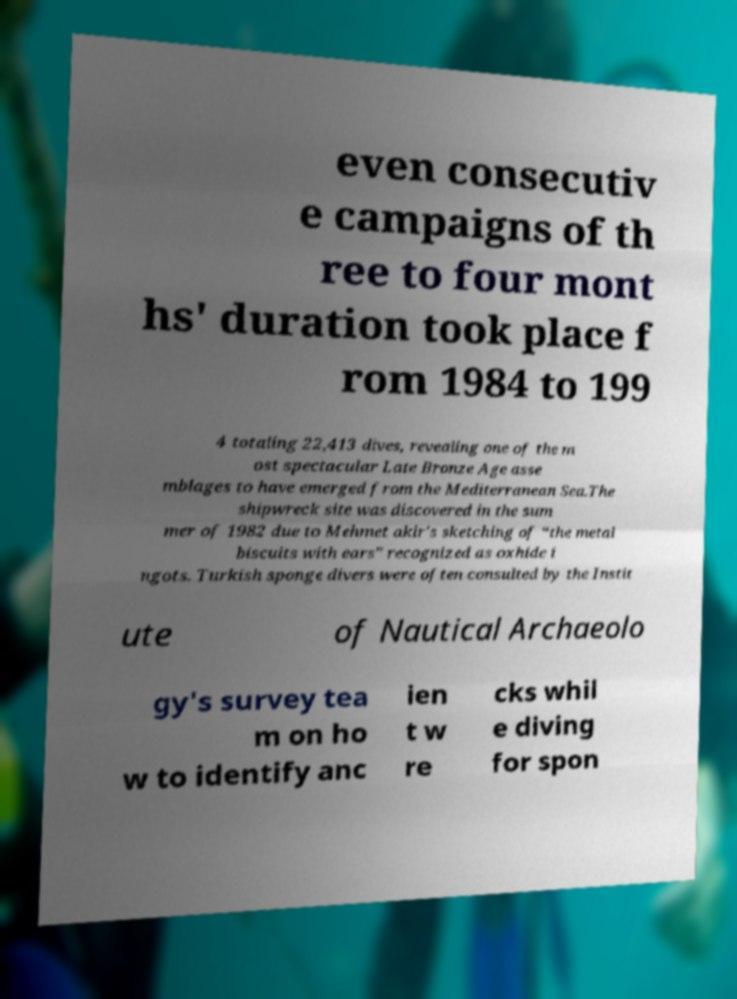Can you accurately transcribe the text from the provided image for me? even consecutiv e campaigns of th ree to four mont hs' duration took place f rom 1984 to 199 4 totaling 22,413 dives, revealing one of the m ost spectacular Late Bronze Age asse mblages to have emerged from the Mediterranean Sea.The shipwreck site was discovered in the sum mer of 1982 due to Mehmet akir's sketching of “the metal biscuits with ears” recognized as oxhide i ngots. Turkish sponge divers were often consulted by the Instit ute of Nautical Archaeolo gy's survey tea m on ho w to identify anc ien t w re cks whil e diving for spon 